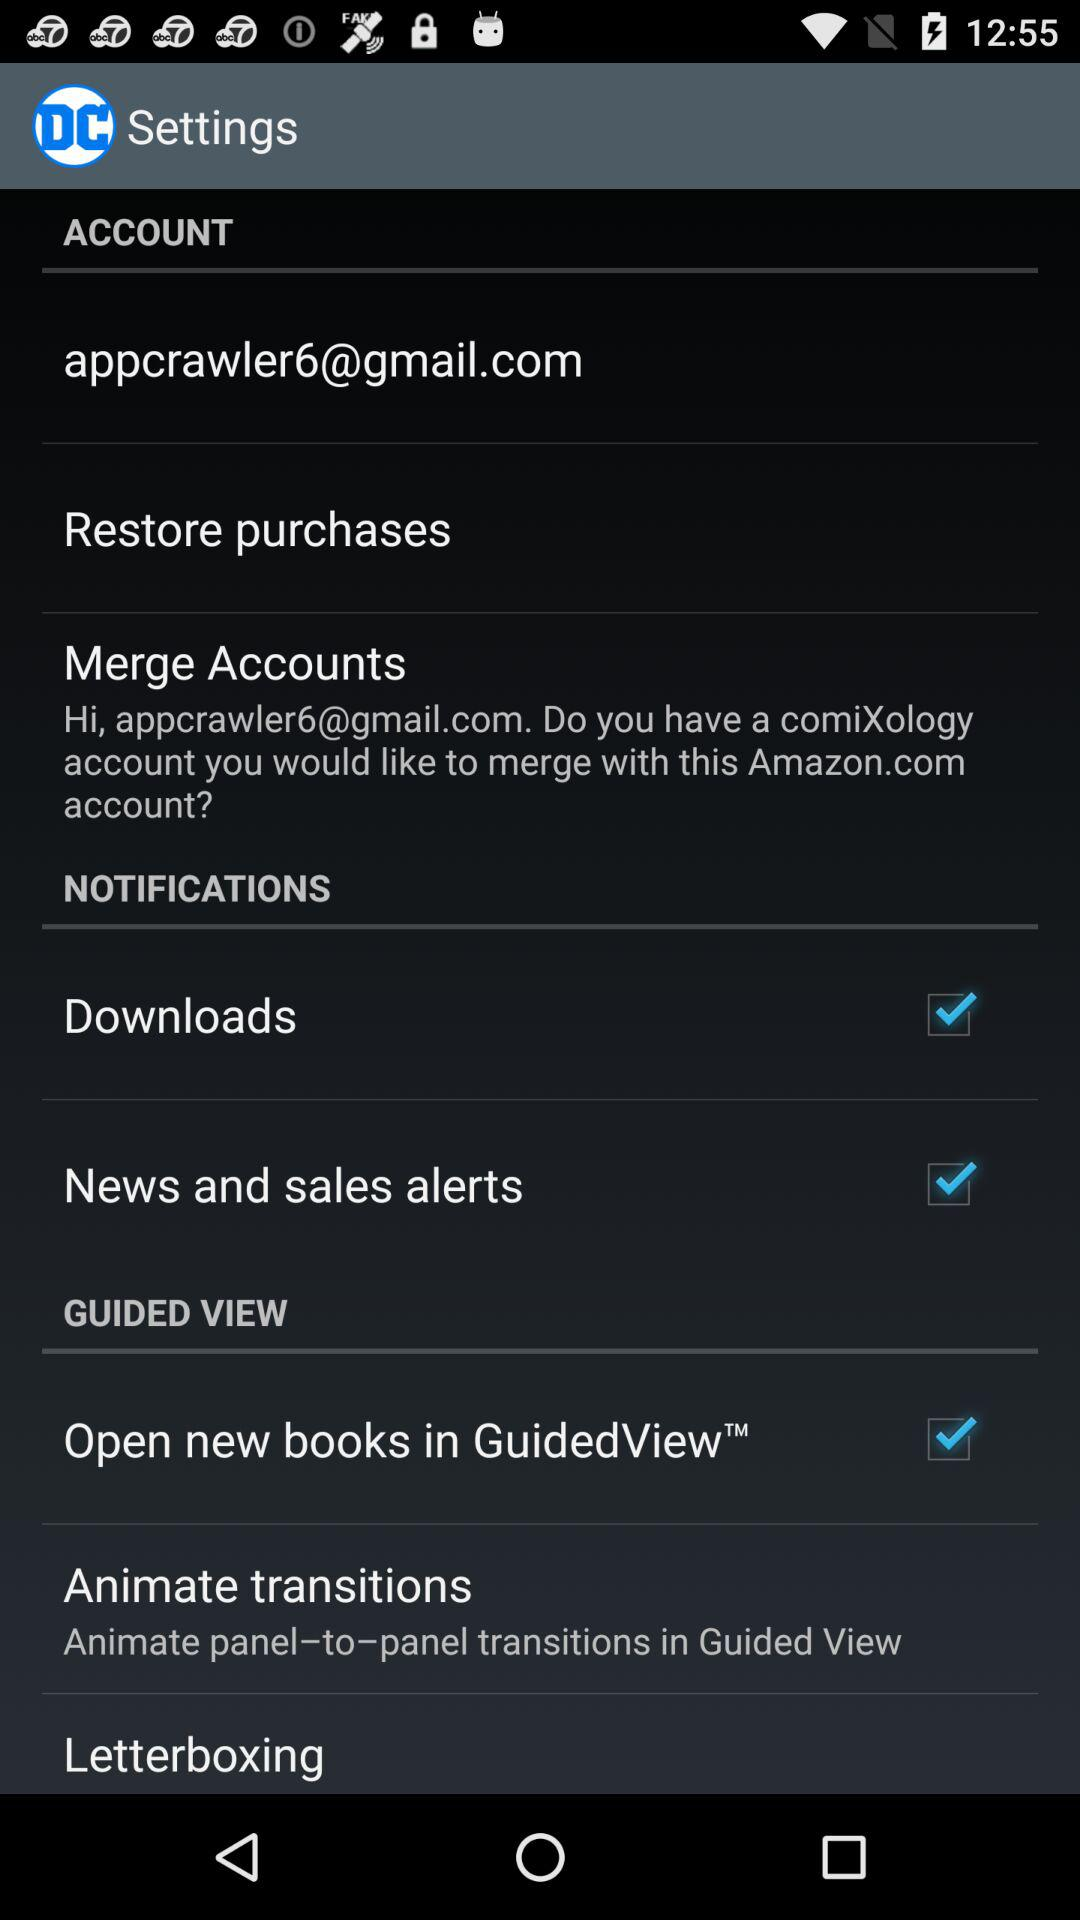What is the email address? The email address is appcrawler6@gmail.com. 